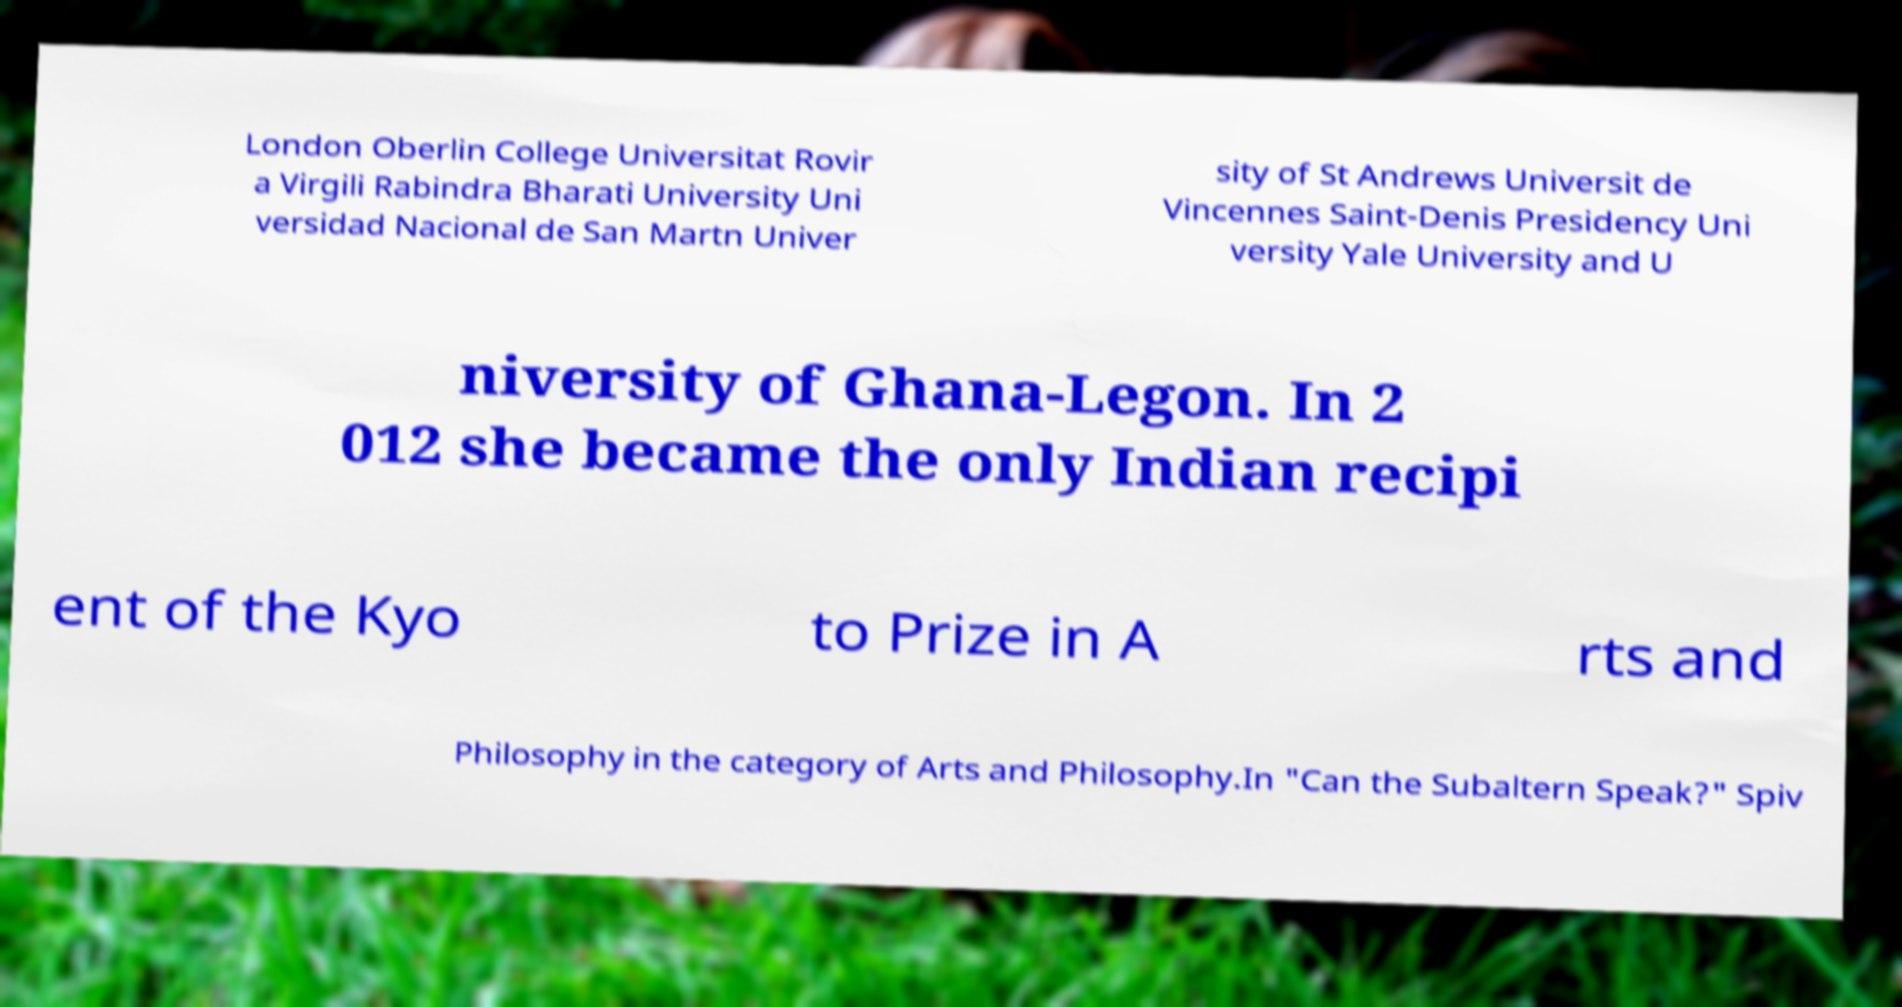Could you assist in decoding the text presented in this image and type it out clearly? London Oberlin College Universitat Rovir a Virgili Rabindra Bharati University Uni versidad Nacional de San Martn Univer sity of St Andrews Universit de Vincennes Saint-Denis Presidency Uni versity Yale University and U niversity of Ghana-Legon. In 2 012 she became the only Indian recipi ent of the Kyo to Prize in A rts and Philosophy in the category of Arts and Philosophy.In "Can the Subaltern Speak?" Spiv 